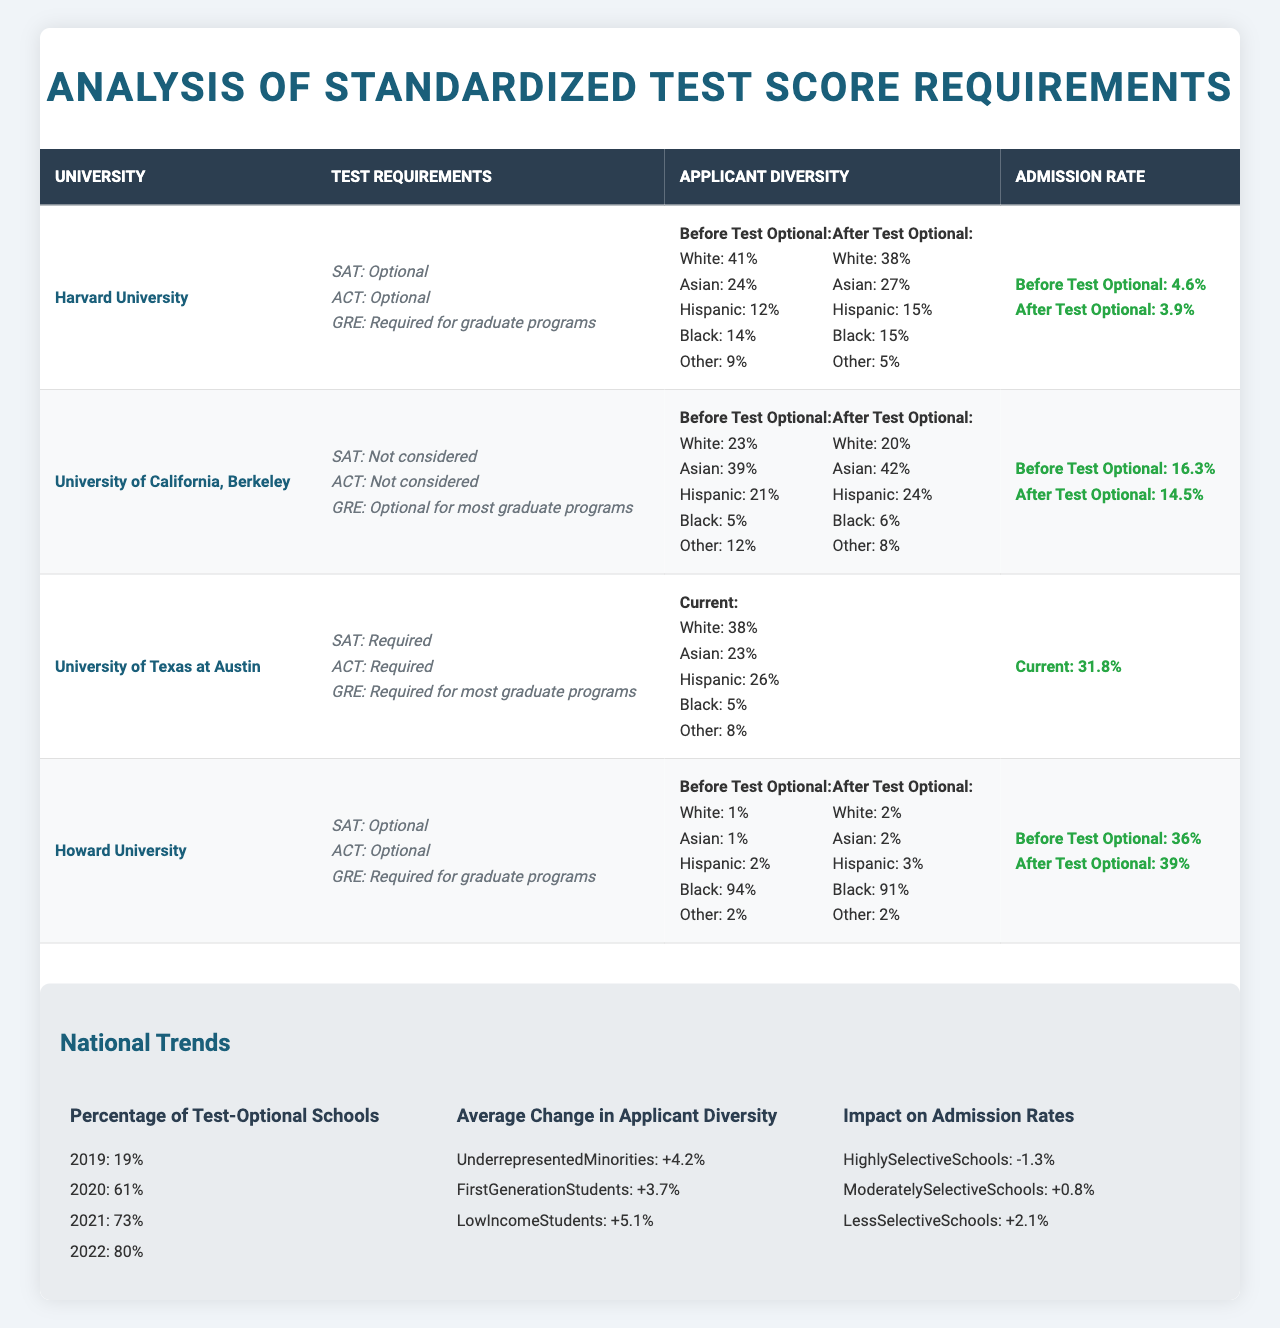What were the admission rates at Harvard University before and after making standardized tests optional? The admission rate before standardized tests became optional was 4.6%, while after it became 3.9%.
Answer: 4.6% (before), 3.9% (after) How much did the percentage of Asian applicants change at Harvard University after making tests optional? The percentage of Asian applicants increased from 24% to 27%, which is a change of 3%.
Answer: +3% Did Howard University see an increase in its admission rate after making standardized tests optional? Yes, Howard University's admission rate increased from 36% before to 39% after it became optional.
Answer: Yes What is the percentage of underrepresented minorities' increase in applicant diversity across universities when standardized tests became optional? The average increase for underrepresented minorities was +4.2% nationwide.
Answer: +4.2% Which university had the highest percentage of Black applicants after going test-optional? Harvard University and Howard University had the same percentage of Black applicants at 15% and 91% respectively after going test-optional; however, Howard had a higher percentage at 91%.
Answer: Howard University (91%) What is the average admission rate change across Highly Selective Schools after making standardized tests optional? The change in admission rates for Highly Selective Schools was a decrease of 1.3%.
Answer: -1.3% How does the percentage of Hispanic applicants differ at the University of California, Berkeley before and after adopting a test-optional policy? The percentage of Hispanic applicants increased from 21% to 24% after the change, a difference of 3%.
Answer: +3% What is the total percentage of White and Black applicants at the University of Texas at Austin? The total percentage is 38% (White) + 5% (Black) = 43%.
Answer: 43% How did the admission rates change for Less Selective Schools after standardized tests were made optional? The admission rates for Less Selective Schools increased by 2.1% after the tests became optional.
Answer: +2.1% Was there a decline in the percentage of White applicants at Harvard University after making tests optional? Yes, the percentage of White applicants declined from 41% to 38%.
Answer: Yes 